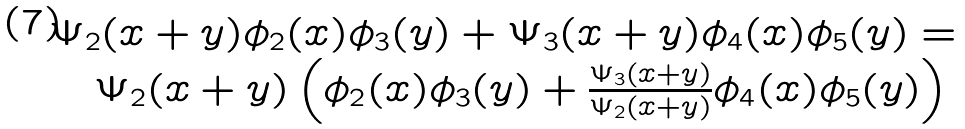<formula> <loc_0><loc_0><loc_500><loc_500>\begin{array} { l } \Psi _ { 2 } ( x + y ) \phi _ { 2 } ( x ) \phi _ { 3 } ( y ) + \Psi _ { 3 } ( x + y ) \phi _ { 4 } ( x ) \phi _ { 5 } ( y ) = \\ \quad \Psi _ { 2 } ( x + y ) \left ( \phi _ { 2 } ( x ) \phi _ { 3 } ( y ) + \frac { \Psi _ { 3 } ( x + y ) } { \Psi _ { 2 } ( x + y ) } \phi _ { 4 } ( x ) \phi _ { 5 } ( y ) \right ) \end{array}</formula> 